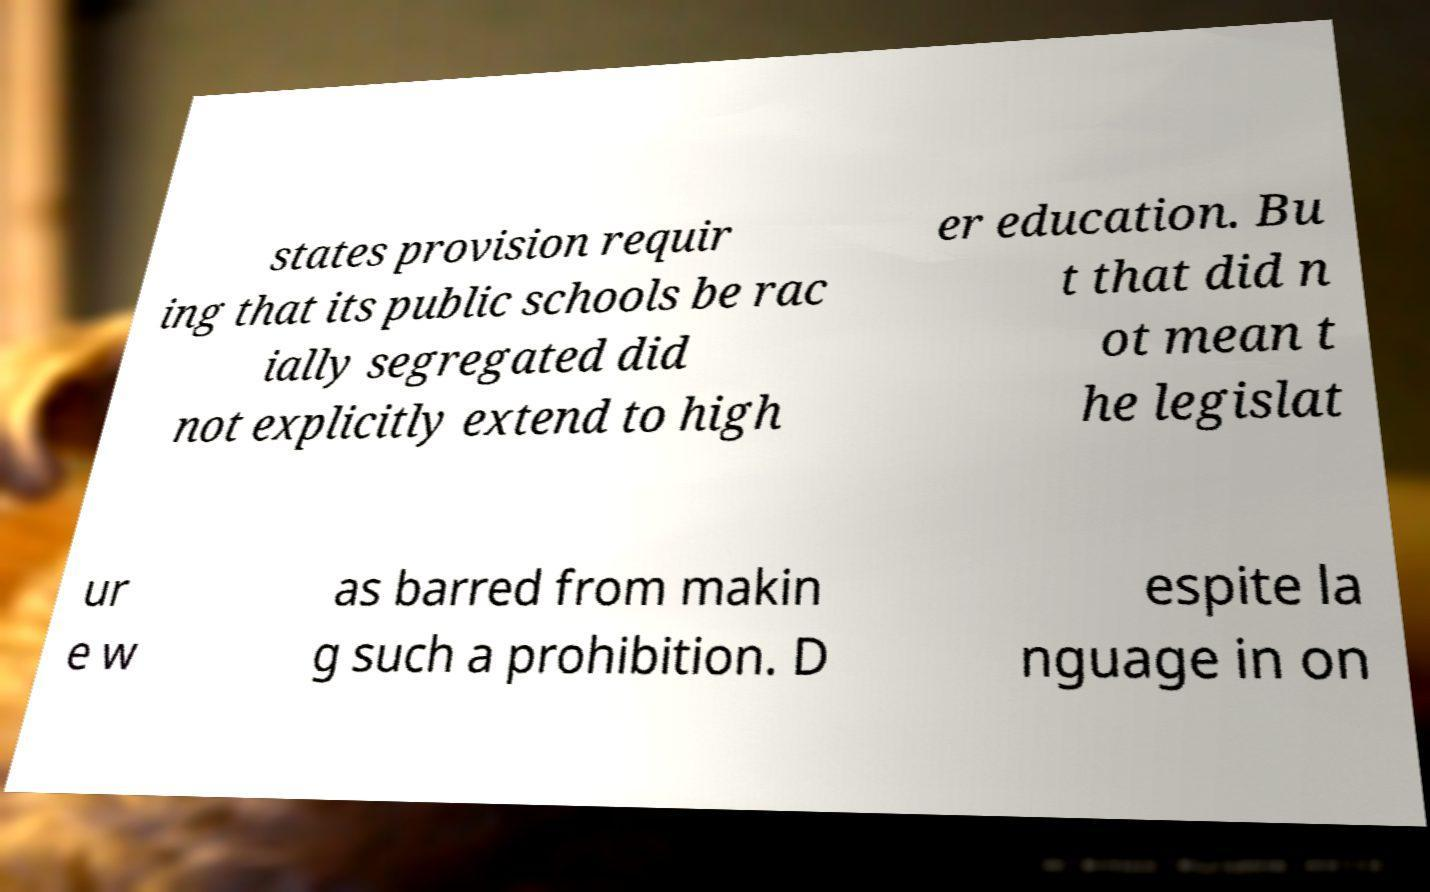Can you accurately transcribe the text from the provided image for me? states provision requir ing that its public schools be rac ially segregated did not explicitly extend to high er education. Bu t that did n ot mean t he legislat ur e w as barred from makin g such a prohibition. D espite la nguage in on 